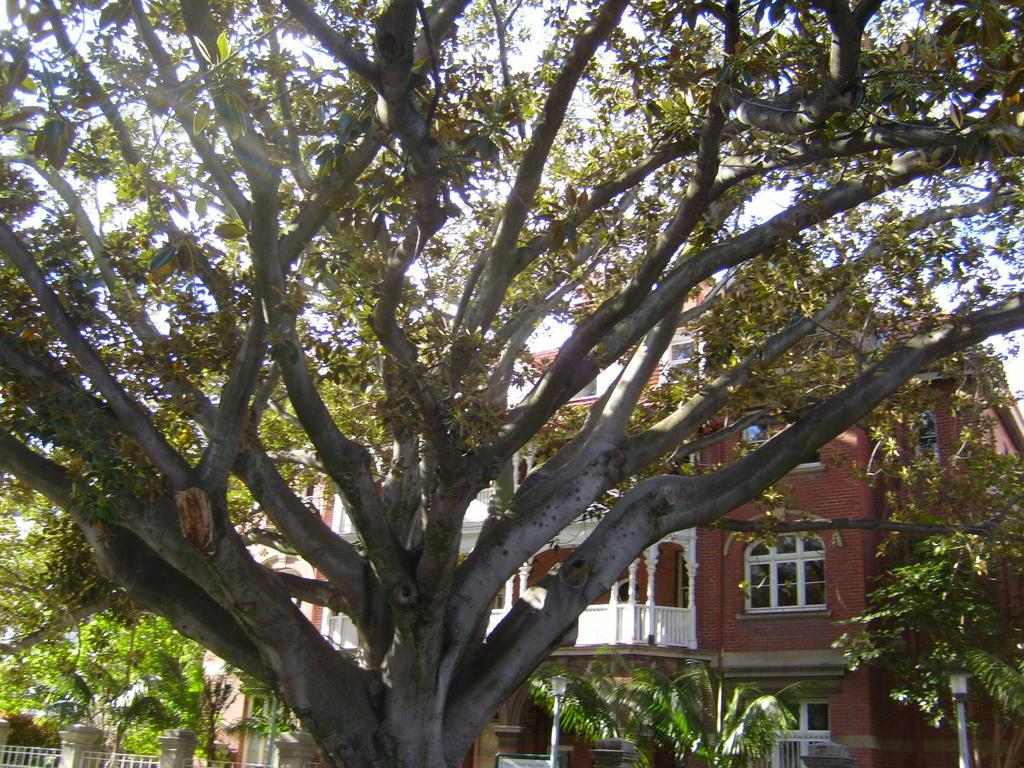What type of vegetation can be seen in the image? There are trees in the image. What is the color of the trees? The trees are green in color. What is visible in the background of the image? There is a building in the background of the image. What is the color of the building? The building is brown and white in color. What is the color of the sky in the image? The sky is white in color. How many sisters are holding flowers in the image? There are no sisters or flowers present in the image. 